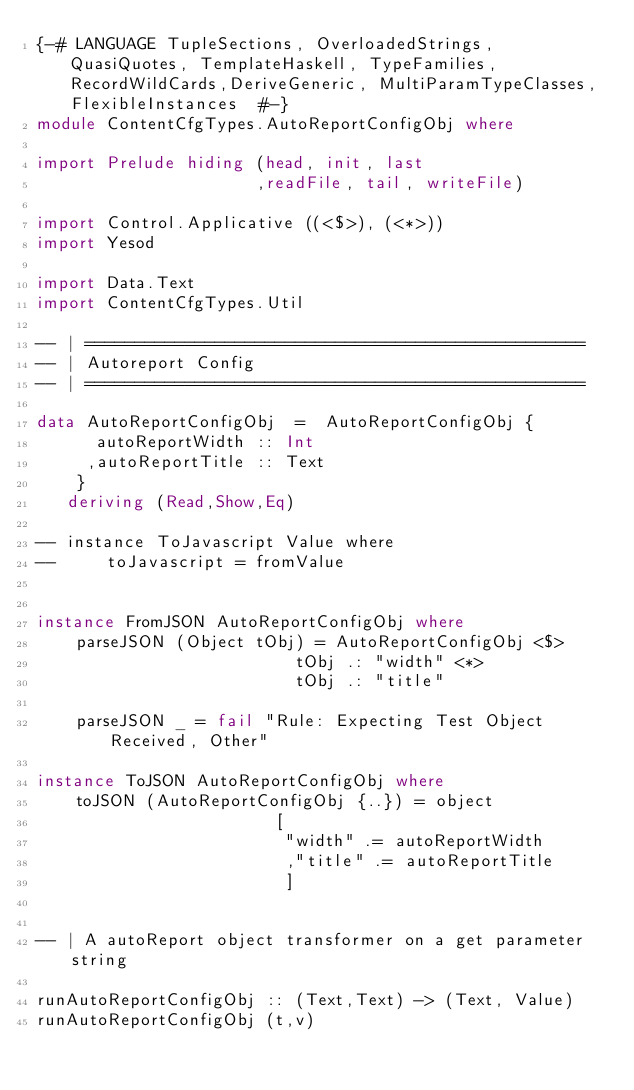<code> <loc_0><loc_0><loc_500><loc_500><_Haskell_>{-# LANGUAGE TupleSections, OverloadedStrings, QuasiQuotes, TemplateHaskell, TypeFamilies, RecordWildCards,DeriveGeneric, MultiParamTypeClasses, FlexibleInstances  #-}
module ContentCfgTypes.AutoReportConfigObj where

import Prelude hiding (head, init, last
                      ,readFile, tail, writeFile)

import Control.Applicative ((<$>), (<*>))
import Yesod 

import Data.Text
import ContentCfgTypes.Util

-- | ==================================================
-- | Autoreport Config 
-- | ================================================== 

data AutoReportConfigObj  =  AutoReportConfigObj { 
      autoReportWidth :: Int
     ,autoReportTitle :: Text
    }
   deriving (Read,Show,Eq)

-- instance ToJavascript Value where 
--     toJavascript = fromValue


instance FromJSON AutoReportConfigObj where 
    parseJSON (Object tObj) = AutoReportConfigObj <$> 
                          tObj .: "width" <*> 
                          tObj .: "title"

    parseJSON _ = fail "Rule: Expecting Test Object Received, Other"

instance ToJSON AutoReportConfigObj where 
    toJSON (AutoReportConfigObj {..}) = object 
                        [ 
                         "width" .= autoReportWidth 
                         ,"title" .= autoReportTitle 
                         ]


-- | A autoReport object transformer on a get parameter string

runAutoReportConfigObj :: (Text,Text) -> (Text, Value)
runAutoReportConfigObj (t,v)</code> 